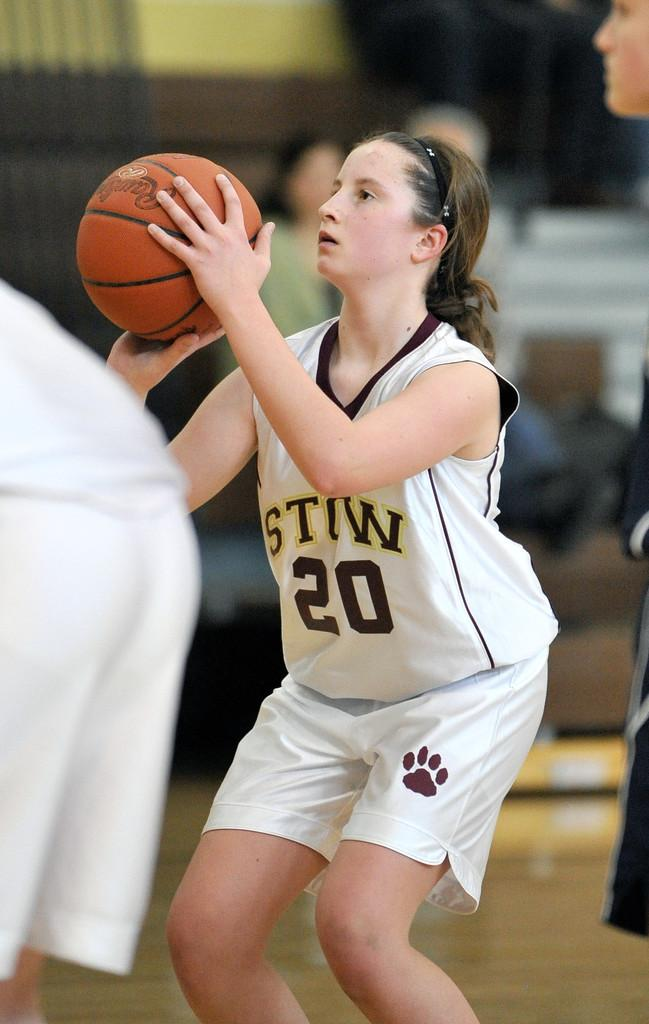Provide a one-sentence caption for the provided image. A girl is ready to shoot a basketball, her uniform has the number 20 on it. 